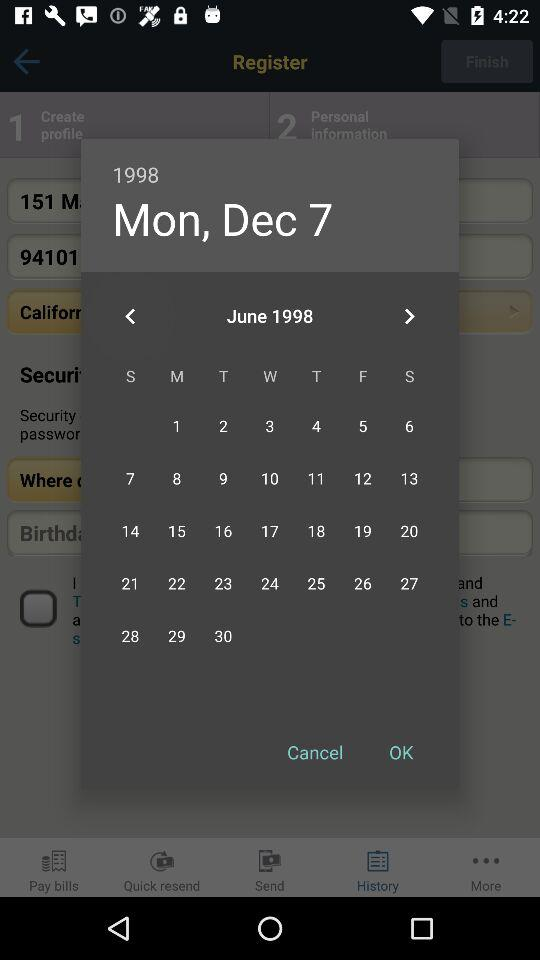What is the name of the application?
When the provided information is insufficient, respond with <no answer>. <no answer> 